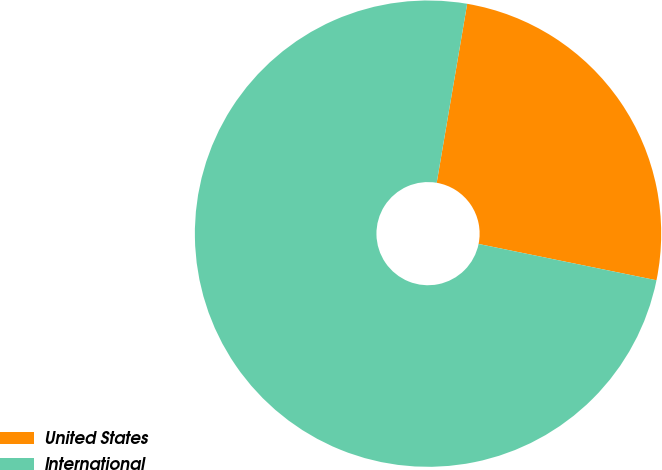Convert chart to OTSL. <chart><loc_0><loc_0><loc_500><loc_500><pie_chart><fcel>United States<fcel>International<nl><fcel>25.52%<fcel>74.48%<nl></chart> 